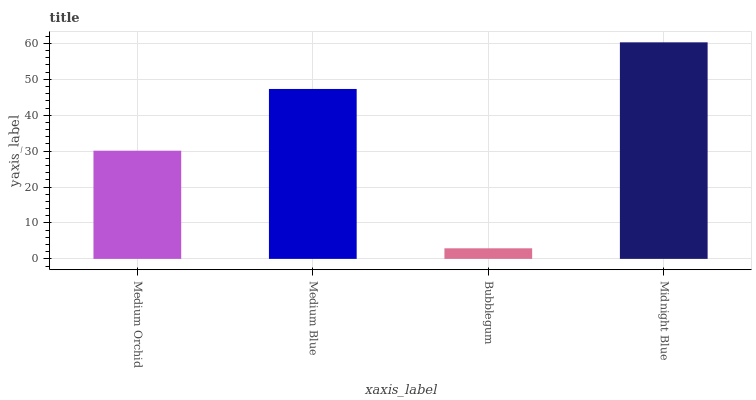Is Bubblegum the minimum?
Answer yes or no. Yes. Is Midnight Blue the maximum?
Answer yes or no. Yes. Is Medium Blue the minimum?
Answer yes or no. No. Is Medium Blue the maximum?
Answer yes or no. No. Is Medium Blue greater than Medium Orchid?
Answer yes or no. Yes. Is Medium Orchid less than Medium Blue?
Answer yes or no. Yes. Is Medium Orchid greater than Medium Blue?
Answer yes or no. No. Is Medium Blue less than Medium Orchid?
Answer yes or no. No. Is Medium Blue the high median?
Answer yes or no. Yes. Is Medium Orchid the low median?
Answer yes or no. Yes. Is Bubblegum the high median?
Answer yes or no. No. Is Midnight Blue the low median?
Answer yes or no. No. 